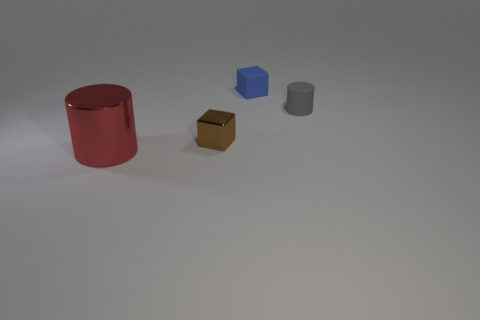Add 1 big red balls. How many objects exist? 5 Subtract all brown blocks. How many blocks are left? 1 Subtract 1 cylinders. How many cylinders are left? 1 Subtract 1 blue blocks. How many objects are left? 3 Subtract all brown cubes. Subtract all yellow spheres. How many cubes are left? 1 Subtract all tiny yellow blocks. Subtract all brown metallic blocks. How many objects are left? 3 Add 1 brown metallic objects. How many brown metallic objects are left? 2 Add 3 tiny gray cylinders. How many tiny gray cylinders exist? 4 